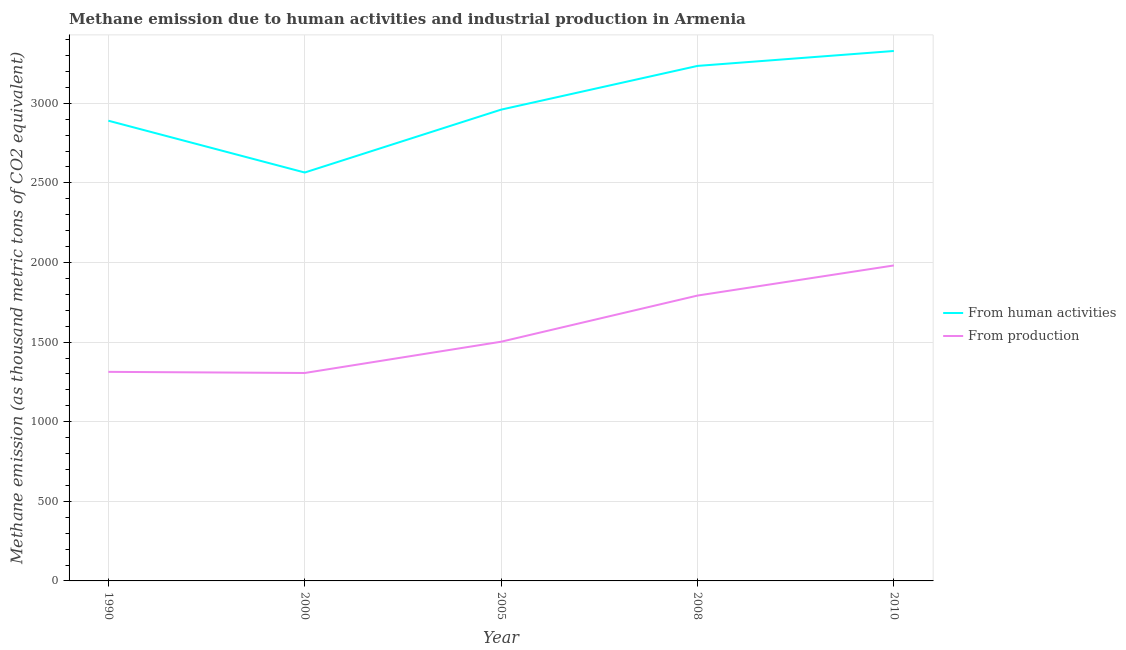How many different coloured lines are there?
Ensure brevity in your answer.  2. Does the line corresponding to amount of emissions generated from industries intersect with the line corresponding to amount of emissions from human activities?
Provide a short and direct response. No. What is the amount of emissions generated from industries in 2005?
Your answer should be very brief. 1502.5. Across all years, what is the maximum amount of emissions generated from industries?
Your answer should be very brief. 1981.6. Across all years, what is the minimum amount of emissions from human activities?
Give a very brief answer. 2565.3. In which year was the amount of emissions from human activities maximum?
Your answer should be compact. 2010. In which year was the amount of emissions from human activities minimum?
Offer a very short reply. 2000. What is the total amount of emissions generated from industries in the graph?
Give a very brief answer. 7895.8. What is the difference between the amount of emissions generated from industries in 1990 and that in 2005?
Your response must be concise. -189.3. What is the difference between the amount of emissions generated from industries in 2010 and the amount of emissions from human activities in 1990?
Offer a terse response. -909.1. What is the average amount of emissions generated from industries per year?
Make the answer very short. 1579.16. In the year 1990, what is the difference between the amount of emissions generated from industries and amount of emissions from human activities?
Offer a terse response. -1577.5. In how many years, is the amount of emissions from human activities greater than 2900 thousand metric tons?
Keep it short and to the point. 3. What is the ratio of the amount of emissions generated from industries in 2000 to that in 2005?
Your answer should be very brief. 0.87. Is the difference between the amount of emissions from human activities in 1990 and 2008 greater than the difference between the amount of emissions generated from industries in 1990 and 2008?
Your answer should be very brief. Yes. What is the difference between the highest and the second highest amount of emissions generated from industries?
Give a very brief answer. 189.2. What is the difference between the highest and the lowest amount of emissions from human activities?
Offer a terse response. 763.4. In how many years, is the amount of emissions generated from industries greater than the average amount of emissions generated from industries taken over all years?
Give a very brief answer. 2. Does the amount of emissions generated from industries monotonically increase over the years?
Provide a short and direct response. No. Is the amount of emissions generated from industries strictly less than the amount of emissions from human activities over the years?
Keep it short and to the point. Yes. How many years are there in the graph?
Give a very brief answer. 5. Does the graph contain any zero values?
Make the answer very short. No. Does the graph contain grids?
Keep it short and to the point. Yes. How many legend labels are there?
Offer a very short reply. 2. What is the title of the graph?
Ensure brevity in your answer.  Methane emission due to human activities and industrial production in Armenia. Does "Male" appear as one of the legend labels in the graph?
Offer a very short reply. No. What is the label or title of the Y-axis?
Provide a succinct answer. Methane emission (as thousand metric tons of CO2 equivalent). What is the Methane emission (as thousand metric tons of CO2 equivalent) in From human activities in 1990?
Your answer should be very brief. 2890.7. What is the Methane emission (as thousand metric tons of CO2 equivalent) in From production in 1990?
Provide a short and direct response. 1313.2. What is the Methane emission (as thousand metric tons of CO2 equivalent) of From human activities in 2000?
Your answer should be very brief. 2565.3. What is the Methane emission (as thousand metric tons of CO2 equivalent) of From production in 2000?
Provide a short and direct response. 1306.1. What is the Methane emission (as thousand metric tons of CO2 equivalent) in From human activities in 2005?
Offer a very short reply. 2960.3. What is the Methane emission (as thousand metric tons of CO2 equivalent) of From production in 2005?
Your answer should be very brief. 1502.5. What is the Methane emission (as thousand metric tons of CO2 equivalent) of From human activities in 2008?
Ensure brevity in your answer.  3234.9. What is the Methane emission (as thousand metric tons of CO2 equivalent) of From production in 2008?
Your response must be concise. 1792.4. What is the Methane emission (as thousand metric tons of CO2 equivalent) of From human activities in 2010?
Offer a very short reply. 3328.7. What is the Methane emission (as thousand metric tons of CO2 equivalent) of From production in 2010?
Provide a short and direct response. 1981.6. Across all years, what is the maximum Methane emission (as thousand metric tons of CO2 equivalent) in From human activities?
Your answer should be compact. 3328.7. Across all years, what is the maximum Methane emission (as thousand metric tons of CO2 equivalent) in From production?
Your response must be concise. 1981.6. Across all years, what is the minimum Methane emission (as thousand metric tons of CO2 equivalent) in From human activities?
Ensure brevity in your answer.  2565.3. Across all years, what is the minimum Methane emission (as thousand metric tons of CO2 equivalent) in From production?
Your response must be concise. 1306.1. What is the total Methane emission (as thousand metric tons of CO2 equivalent) of From human activities in the graph?
Your response must be concise. 1.50e+04. What is the total Methane emission (as thousand metric tons of CO2 equivalent) in From production in the graph?
Your response must be concise. 7895.8. What is the difference between the Methane emission (as thousand metric tons of CO2 equivalent) of From human activities in 1990 and that in 2000?
Provide a succinct answer. 325.4. What is the difference between the Methane emission (as thousand metric tons of CO2 equivalent) in From production in 1990 and that in 2000?
Give a very brief answer. 7.1. What is the difference between the Methane emission (as thousand metric tons of CO2 equivalent) of From human activities in 1990 and that in 2005?
Offer a terse response. -69.6. What is the difference between the Methane emission (as thousand metric tons of CO2 equivalent) in From production in 1990 and that in 2005?
Provide a succinct answer. -189.3. What is the difference between the Methane emission (as thousand metric tons of CO2 equivalent) in From human activities in 1990 and that in 2008?
Keep it short and to the point. -344.2. What is the difference between the Methane emission (as thousand metric tons of CO2 equivalent) in From production in 1990 and that in 2008?
Offer a very short reply. -479.2. What is the difference between the Methane emission (as thousand metric tons of CO2 equivalent) of From human activities in 1990 and that in 2010?
Your answer should be very brief. -438. What is the difference between the Methane emission (as thousand metric tons of CO2 equivalent) in From production in 1990 and that in 2010?
Make the answer very short. -668.4. What is the difference between the Methane emission (as thousand metric tons of CO2 equivalent) in From human activities in 2000 and that in 2005?
Offer a terse response. -395. What is the difference between the Methane emission (as thousand metric tons of CO2 equivalent) in From production in 2000 and that in 2005?
Your answer should be very brief. -196.4. What is the difference between the Methane emission (as thousand metric tons of CO2 equivalent) of From human activities in 2000 and that in 2008?
Offer a very short reply. -669.6. What is the difference between the Methane emission (as thousand metric tons of CO2 equivalent) of From production in 2000 and that in 2008?
Provide a short and direct response. -486.3. What is the difference between the Methane emission (as thousand metric tons of CO2 equivalent) in From human activities in 2000 and that in 2010?
Your answer should be very brief. -763.4. What is the difference between the Methane emission (as thousand metric tons of CO2 equivalent) in From production in 2000 and that in 2010?
Your answer should be compact. -675.5. What is the difference between the Methane emission (as thousand metric tons of CO2 equivalent) of From human activities in 2005 and that in 2008?
Offer a terse response. -274.6. What is the difference between the Methane emission (as thousand metric tons of CO2 equivalent) in From production in 2005 and that in 2008?
Your answer should be compact. -289.9. What is the difference between the Methane emission (as thousand metric tons of CO2 equivalent) of From human activities in 2005 and that in 2010?
Your answer should be compact. -368.4. What is the difference between the Methane emission (as thousand metric tons of CO2 equivalent) of From production in 2005 and that in 2010?
Keep it short and to the point. -479.1. What is the difference between the Methane emission (as thousand metric tons of CO2 equivalent) in From human activities in 2008 and that in 2010?
Make the answer very short. -93.8. What is the difference between the Methane emission (as thousand metric tons of CO2 equivalent) of From production in 2008 and that in 2010?
Offer a terse response. -189.2. What is the difference between the Methane emission (as thousand metric tons of CO2 equivalent) in From human activities in 1990 and the Methane emission (as thousand metric tons of CO2 equivalent) in From production in 2000?
Keep it short and to the point. 1584.6. What is the difference between the Methane emission (as thousand metric tons of CO2 equivalent) of From human activities in 1990 and the Methane emission (as thousand metric tons of CO2 equivalent) of From production in 2005?
Make the answer very short. 1388.2. What is the difference between the Methane emission (as thousand metric tons of CO2 equivalent) of From human activities in 1990 and the Methane emission (as thousand metric tons of CO2 equivalent) of From production in 2008?
Ensure brevity in your answer.  1098.3. What is the difference between the Methane emission (as thousand metric tons of CO2 equivalent) of From human activities in 1990 and the Methane emission (as thousand metric tons of CO2 equivalent) of From production in 2010?
Offer a very short reply. 909.1. What is the difference between the Methane emission (as thousand metric tons of CO2 equivalent) in From human activities in 2000 and the Methane emission (as thousand metric tons of CO2 equivalent) in From production in 2005?
Give a very brief answer. 1062.8. What is the difference between the Methane emission (as thousand metric tons of CO2 equivalent) in From human activities in 2000 and the Methane emission (as thousand metric tons of CO2 equivalent) in From production in 2008?
Give a very brief answer. 772.9. What is the difference between the Methane emission (as thousand metric tons of CO2 equivalent) of From human activities in 2000 and the Methane emission (as thousand metric tons of CO2 equivalent) of From production in 2010?
Make the answer very short. 583.7. What is the difference between the Methane emission (as thousand metric tons of CO2 equivalent) in From human activities in 2005 and the Methane emission (as thousand metric tons of CO2 equivalent) in From production in 2008?
Provide a succinct answer. 1167.9. What is the difference between the Methane emission (as thousand metric tons of CO2 equivalent) of From human activities in 2005 and the Methane emission (as thousand metric tons of CO2 equivalent) of From production in 2010?
Provide a short and direct response. 978.7. What is the difference between the Methane emission (as thousand metric tons of CO2 equivalent) in From human activities in 2008 and the Methane emission (as thousand metric tons of CO2 equivalent) in From production in 2010?
Provide a succinct answer. 1253.3. What is the average Methane emission (as thousand metric tons of CO2 equivalent) of From human activities per year?
Your answer should be compact. 2995.98. What is the average Methane emission (as thousand metric tons of CO2 equivalent) in From production per year?
Keep it short and to the point. 1579.16. In the year 1990, what is the difference between the Methane emission (as thousand metric tons of CO2 equivalent) of From human activities and Methane emission (as thousand metric tons of CO2 equivalent) of From production?
Your answer should be very brief. 1577.5. In the year 2000, what is the difference between the Methane emission (as thousand metric tons of CO2 equivalent) of From human activities and Methane emission (as thousand metric tons of CO2 equivalent) of From production?
Ensure brevity in your answer.  1259.2. In the year 2005, what is the difference between the Methane emission (as thousand metric tons of CO2 equivalent) in From human activities and Methane emission (as thousand metric tons of CO2 equivalent) in From production?
Provide a succinct answer. 1457.8. In the year 2008, what is the difference between the Methane emission (as thousand metric tons of CO2 equivalent) in From human activities and Methane emission (as thousand metric tons of CO2 equivalent) in From production?
Your answer should be very brief. 1442.5. In the year 2010, what is the difference between the Methane emission (as thousand metric tons of CO2 equivalent) in From human activities and Methane emission (as thousand metric tons of CO2 equivalent) in From production?
Make the answer very short. 1347.1. What is the ratio of the Methane emission (as thousand metric tons of CO2 equivalent) in From human activities in 1990 to that in 2000?
Your answer should be very brief. 1.13. What is the ratio of the Methane emission (as thousand metric tons of CO2 equivalent) in From production in 1990 to that in 2000?
Your answer should be very brief. 1.01. What is the ratio of the Methane emission (as thousand metric tons of CO2 equivalent) in From human activities in 1990 to that in 2005?
Make the answer very short. 0.98. What is the ratio of the Methane emission (as thousand metric tons of CO2 equivalent) of From production in 1990 to that in 2005?
Ensure brevity in your answer.  0.87. What is the ratio of the Methane emission (as thousand metric tons of CO2 equivalent) in From human activities in 1990 to that in 2008?
Your answer should be very brief. 0.89. What is the ratio of the Methane emission (as thousand metric tons of CO2 equivalent) in From production in 1990 to that in 2008?
Offer a terse response. 0.73. What is the ratio of the Methane emission (as thousand metric tons of CO2 equivalent) in From human activities in 1990 to that in 2010?
Keep it short and to the point. 0.87. What is the ratio of the Methane emission (as thousand metric tons of CO2 equivalent) of From production in 1990 to that in 2010?
Provide a succinct answer. 0.66. What is the ratio of the Methane emission (as thousand metric tons of CO2 equivalent) of From human activities in 2000 to that in 2005?
Your response must be concise. 0.87. What is the ratio of the Methane emission (as thousand metric tons of CO2 equivalent) in From production in 2000 to that in 2005?
Offer a terse response. 0.87. What is the ratio of the Methane emission (as thousand metric tons of CO2 equivalent) in From human activities in 2000 to that in 2008?
Offer a very short reply. 0.79. What is the ratio of the Methane emission (as thousand metric tons of CO2 equivalent) in From production in 2000 to that in 2008?
Your answer should be compact. 0.73. What is the ratio of the Methane emission (as thousand metric tons of CO2 equivalent) in From human activities in 2000 to that in 2010?
Offer a very short reply. 0.77. What is the ratio of the Methane emission (as thousand metric tons of CO2 equivalent) in From production in 2000 to that in 2010?
Provide a short and direct response. 0.66. What is the ratio of the Methane emission (as thousand metric tons of CO2 equivalent) in From human activities in 2005 to that in 2008?
Provide a short and direct response. 0.92. What is the ratio of the Methane emission (as thousand metric tons of CO2 equivalent) of From production in 2005 to that in 2008?
Give a very brief answer. 0.84. What is the ratio of the Methane emission (as thousand metric tons of CO2 equivalent) in From human activities in 2005 to that in 2010?
Your response must be concise. 0.89. What is the ratio of the Methane emission (as thousand metric tons of CO2 equivalent) in From production in 2005 to that in 2010?
Your response must be concise. 0.76. What is the ratio of the Methane emission (as thousand metric tons of CO2 equivalent) of From human activities in 2008 to that in 2010?
Provide a short and direct response. 0.97. What is the ratio of the Methane emission (as thousand metric tons of CO2 equivalent) in From production in 2008 to that in 2010?
Provide a short and direct response. 0.9. What is the difference between the highest and the second highest Methane emission (as thousand metric tons of CO2 equivalent) in From human activities?
Make the answer very short. 93.8. What is the difference between the highest and the second highest Methane emission (as thousand metric tons of CO2 equivalent) of From production?
Your answer should be very brief. 189.2. What is the difference between the highest and the lowest Methane emission (as thousand metric tons of CO2 equivalent) in From human activities?
Provide a succinct answer. 763.4. What is the difference between the highest and the lowest Methane emission (as thousand metric tons of CO2 equivalent) of From production?
Provide a succinct answer. 675.5. 